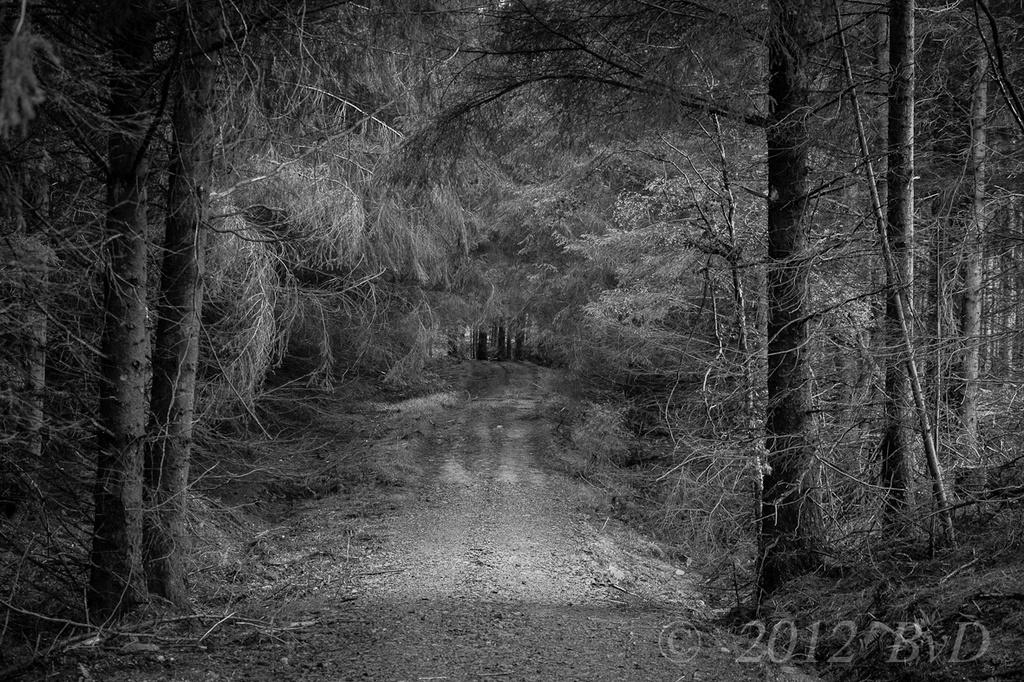What is the color scheme of the image? The image is black and white. What can be seen on the ground in the image? There is a path in the image. What type of vegetation is present in the image? There are trees in the image. Is there any text or logo visible on the image? Yes, there is a watermark on the image. Can you tell me how many bushes are located near the lake in the image? There is no lake or bushes present in the image; it features a black and white scene with a path and trees. What type of shade is provided by the trees in the image? There is no mention of shade in the image, as it is a black and white image with no indication of sunlight or shadows. 